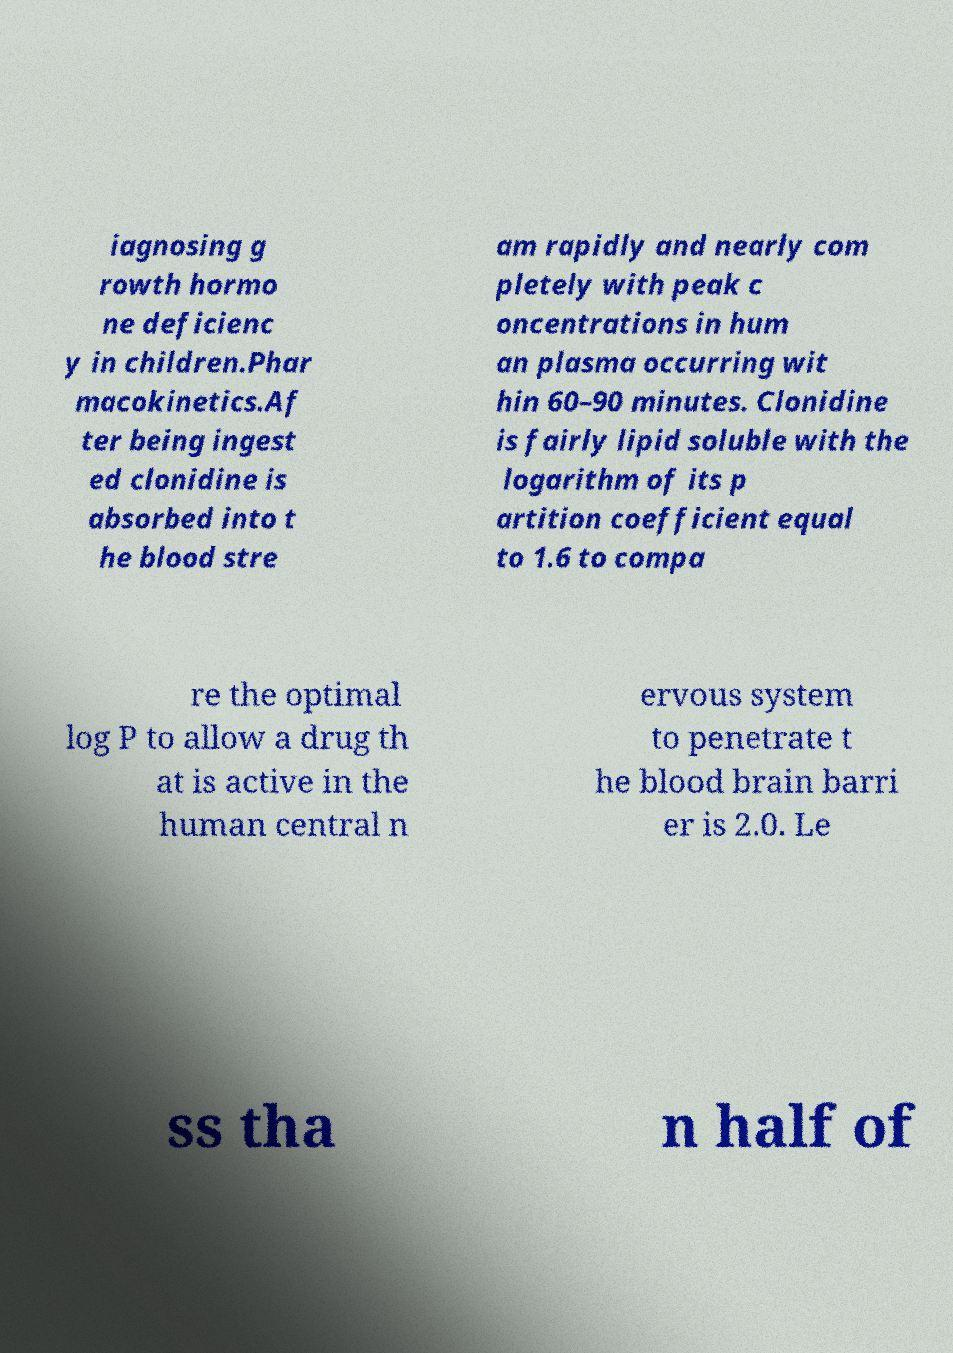Please read and relay the text visible in this image. What does it say? iagnosing g rowth hormo ne deficienc y in children.Phar macokinetics.Af ter being ingest ed clonidine is absorbed into t he blood stre am rapidly and nearly com pletely with peak c oncentrations in hum an plasma occurring wit hin 60–90 minutes. Clonidine is fairly lipid soluble with the logarithm of its p artition coefficient equal to 1.6 to compa re the optimal log P to allow a drug th at is active in the human central n ervous system to penetrate t he blood brain barri er is 2.0. Le ss tha n half of 